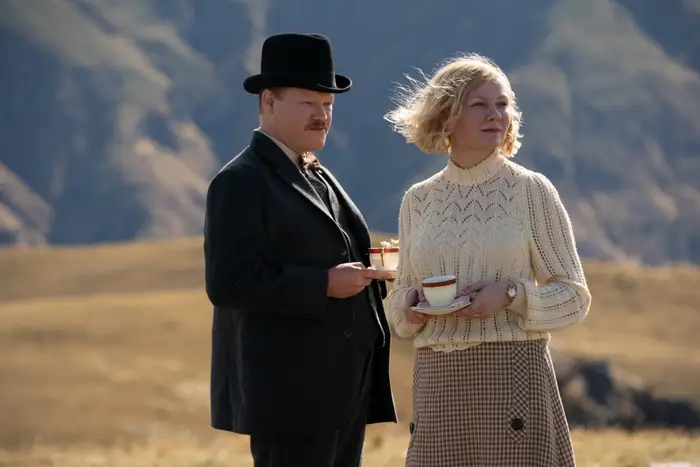Can you describe the main features of this image for me? The image captures a poignant moment between two characters dressed in early 20th-century attire, standing in a stark, mountainous landscape that accentuates the scene's solemn mood. The man, dressed in a formal black suit and top hat, holds a tray with tea cups, suggesting a role of service or care. The woman, clad in a classic white sweater and a checkered skirt, holds a tea cup, her face reflecting a contemplative or somber mood. The vast, open landscape around them not only highlights their isolation but also seems to echo the emotional distance that might be between them, suggestive of deep, unspoken narratives. 